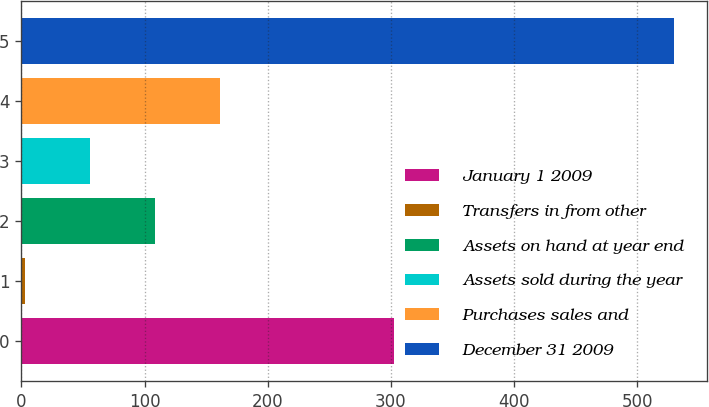<chart> <loc_0><loc_0><loc_500><loc_500><bar_chart><fcel>January 1 2009<fcel>Transfers in from other<fcel>Assets on hand at year end<fcel>Assets sold during the year<fcel>Purchases sales and<fcel>December 31 2009<nl><fcel>303<fcel>3<fcel>108.4<fcel>55.7<fcel>161.1<fcel>530<nl></chart> 